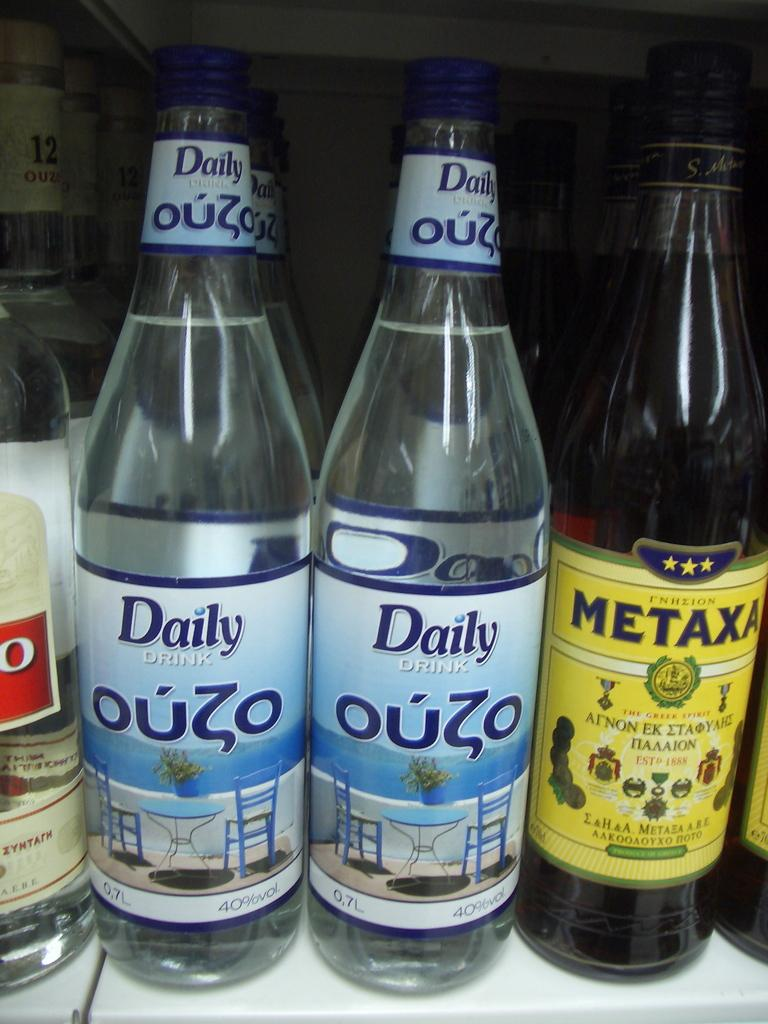<image>
Summarize the visual content of the image. Daily Drink OuZo is printed on the label of these bottles. 